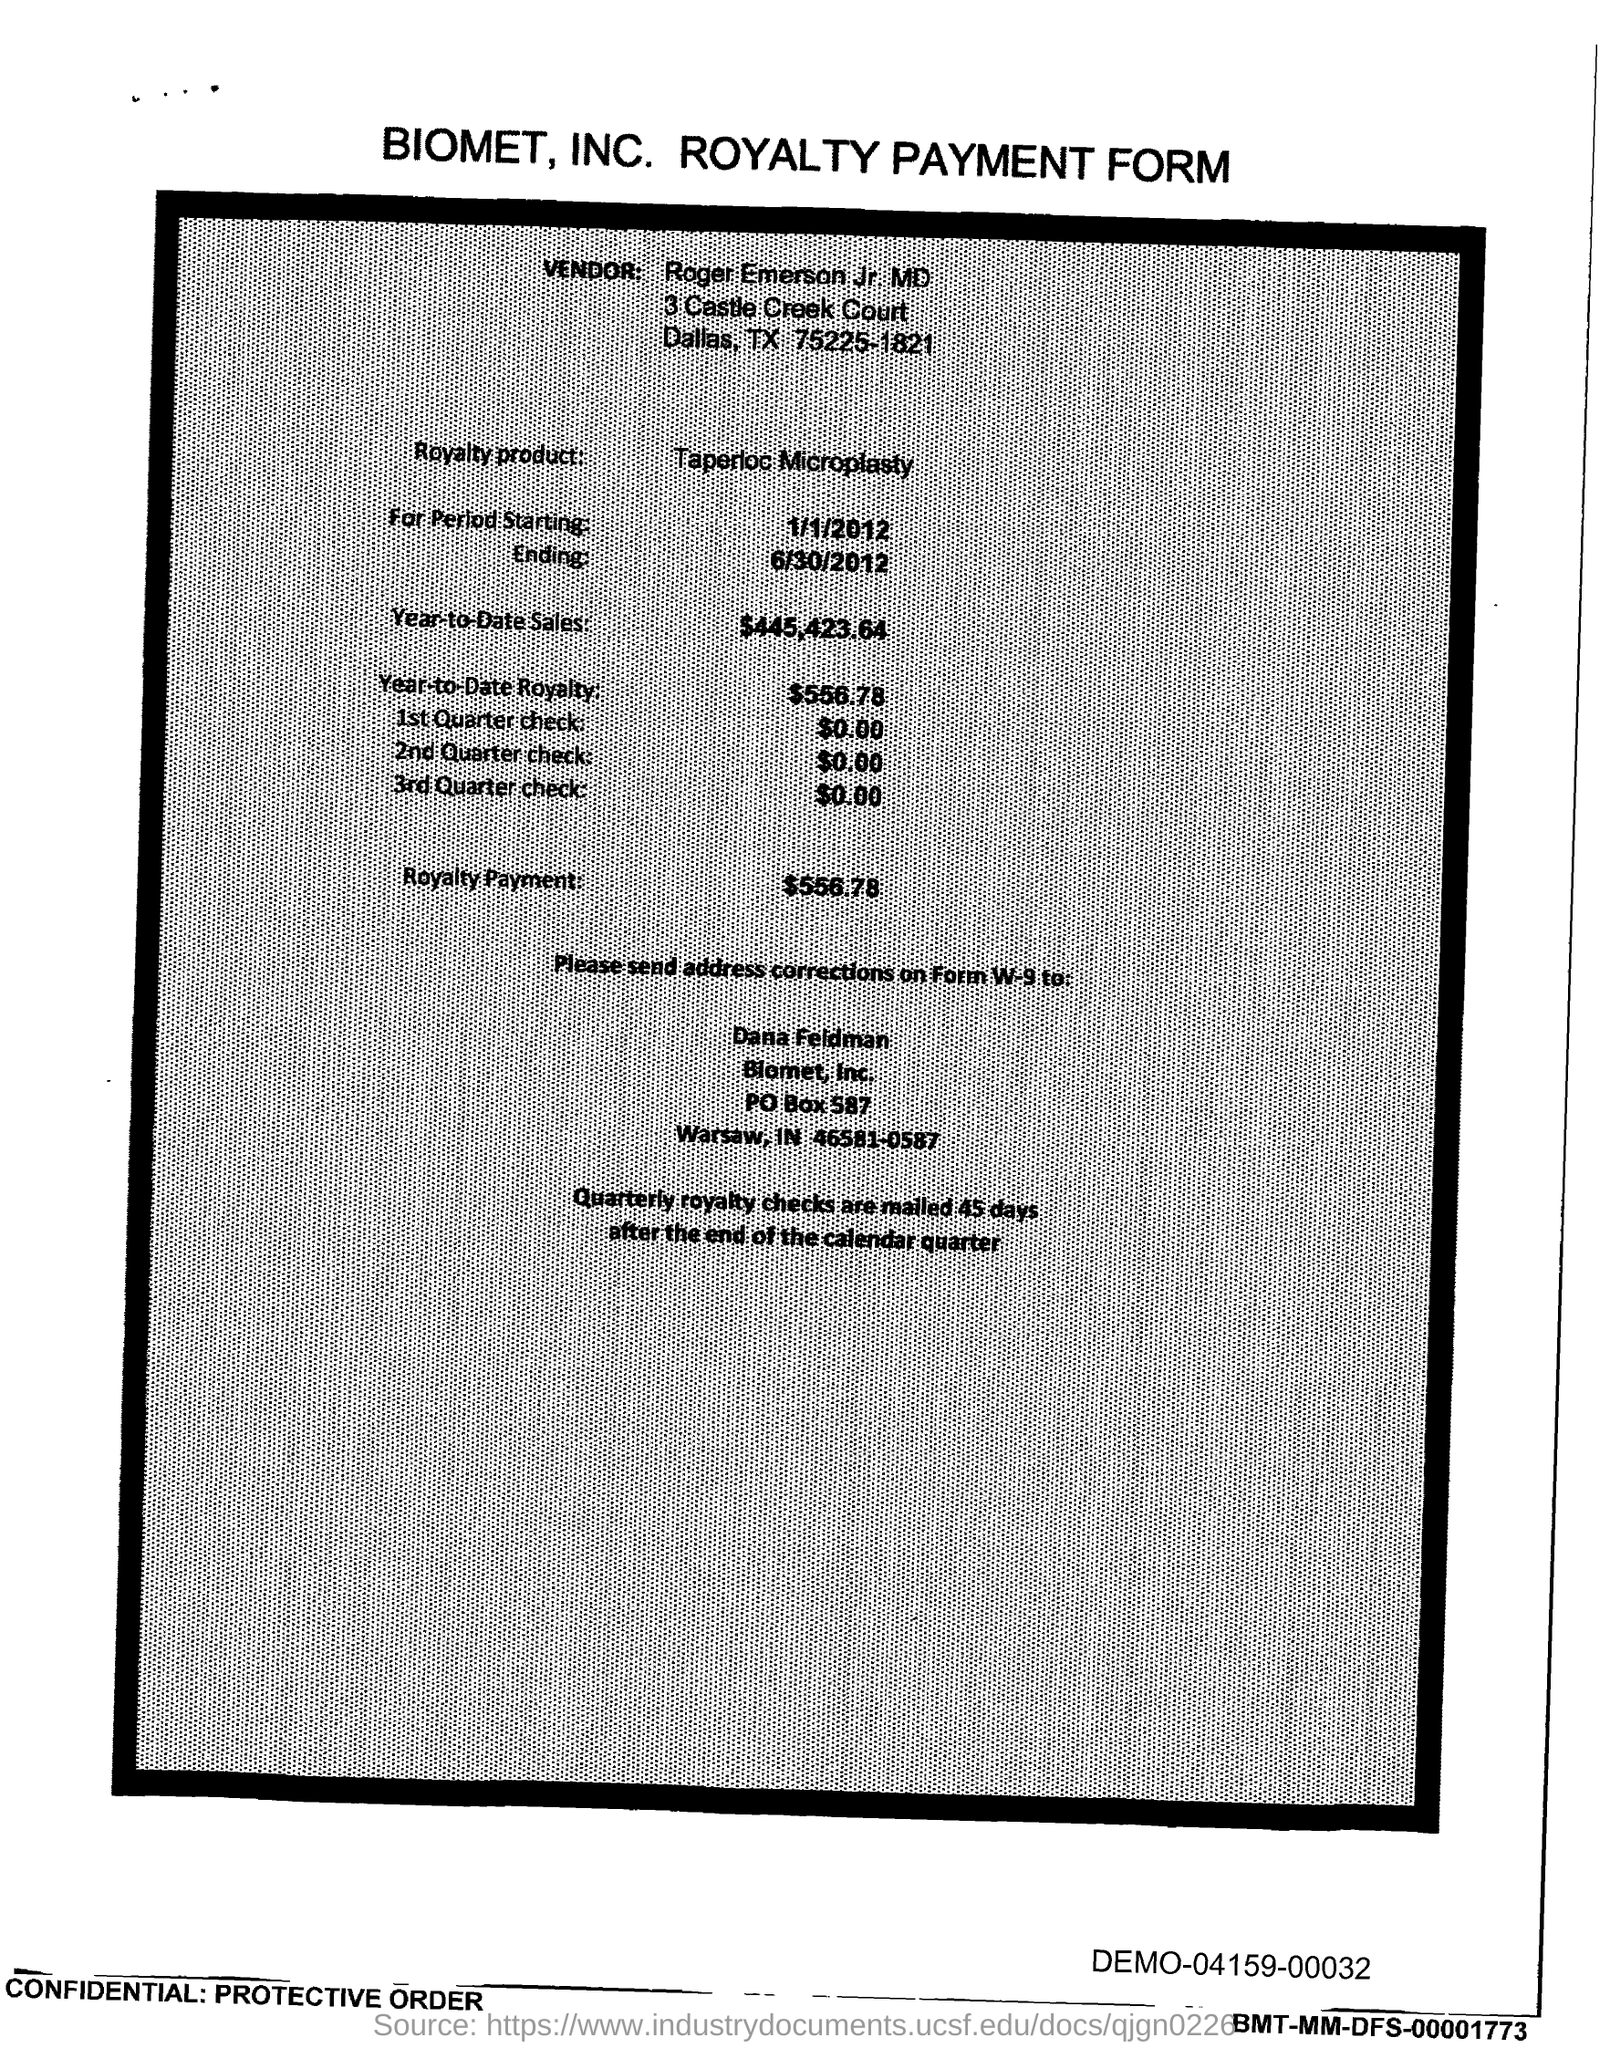Who is the vendor?
Make the answer very short. Roger Emerson Jr. MD. What is the royalty product?
Your answer should be very brief. Taperloc Microplasty. What is the starting period?
Your answer should be very brief. 1/1/2012. What is the ending period mentioned?
Your answer should be very brief. 6/30/2012. What is the Year-to-Date Sales?
Provide a succinct answer. $445,423.64. What is the Year-to-Date royalty?
Make the answer very short. $556.78. What is the Royalty payment?
Offer a terse response. $556.78. 